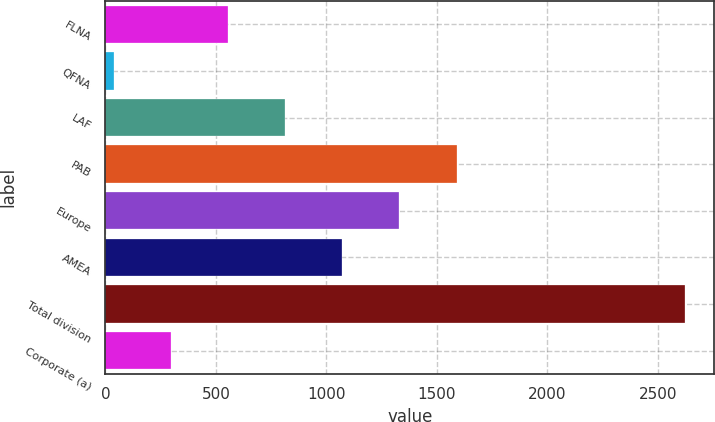<chart> <loc_0><loc_0><loc_500><loc_500><bar_chart><fcel>FLNA<fcel>QFNA<fcel>LAF<fcel>PAB<fcel>Europe<fcel>AMEA<fcel>Total division<fcel>Corporate (a)<nl><fcel>554.6<fcel>37<fcel>813.4<fcel>1589.8<fcel>1331<fcel>1072.2<fcel>2625<fcel>295.8<nl></chart> 